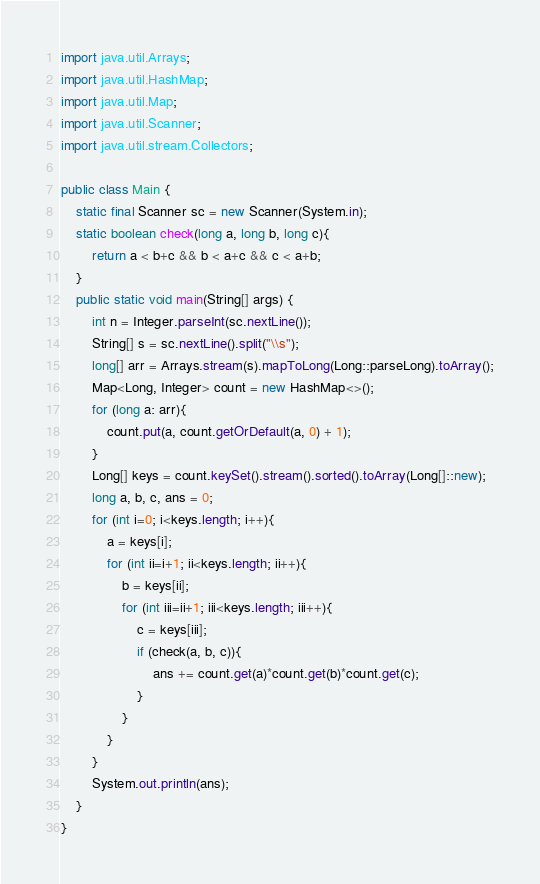<code> <loc_0><loc_0><loc_500><loc_500><_Java_>import java.util.Arrays;
import java.util.HashMap;
import java.util.Map;
import java.util.Scanner;
import java.util.stream.Collectors;

public class Main {
    static final Scanner sc = new Scanner(System.in);
    static boolean check(long a, long b, long c){
        return a < b+c && b < a+c && c < a+b;
    }
    public static void main(String[] args) {
        int n = Integer.parseInt(sc.nextLine());
        String[] s = sc.nextLine().split("\\s");
        long[] arr = Arrays.stream(s).mapToLong(Long::parseLong).toArray();
        Map<Long, Integer> count = new HashMap<>(); 
        for (long a: arr){
            count.put(a, count.getOrDefault(a, 0) + 1);
        }
        Long[] keys = count.keySet().stream().sorted().toArray(Long[]::new);
        long a, b, c, ans = 0;
        for (int i=0; i<keys.length; i++){
            a = keys[i];
            for (int ii=i+1; ii<keys.length; ii++){
                b = keys[ii];
                for (int iii=ii+1; iii<keys.length; iii++){
                    c = keys[iii]; 
                    if (check(a, b, c)){
                        ans += count.get(a)*count.get(b)*count.get(c);
                    }
                }
            }
        }
        System.out.println(ans);
    }
}</code> 